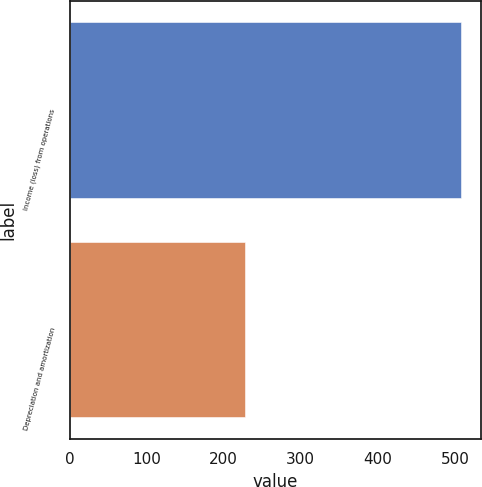Convert chart. <chart><loc_0><loc_0><loc_500><loc_500><bar_chart><fcel>Income (loss) from operations<fcel>Depreciation and amortization<nl><fcel>508.6<fcel>227.4<nl></chart> 